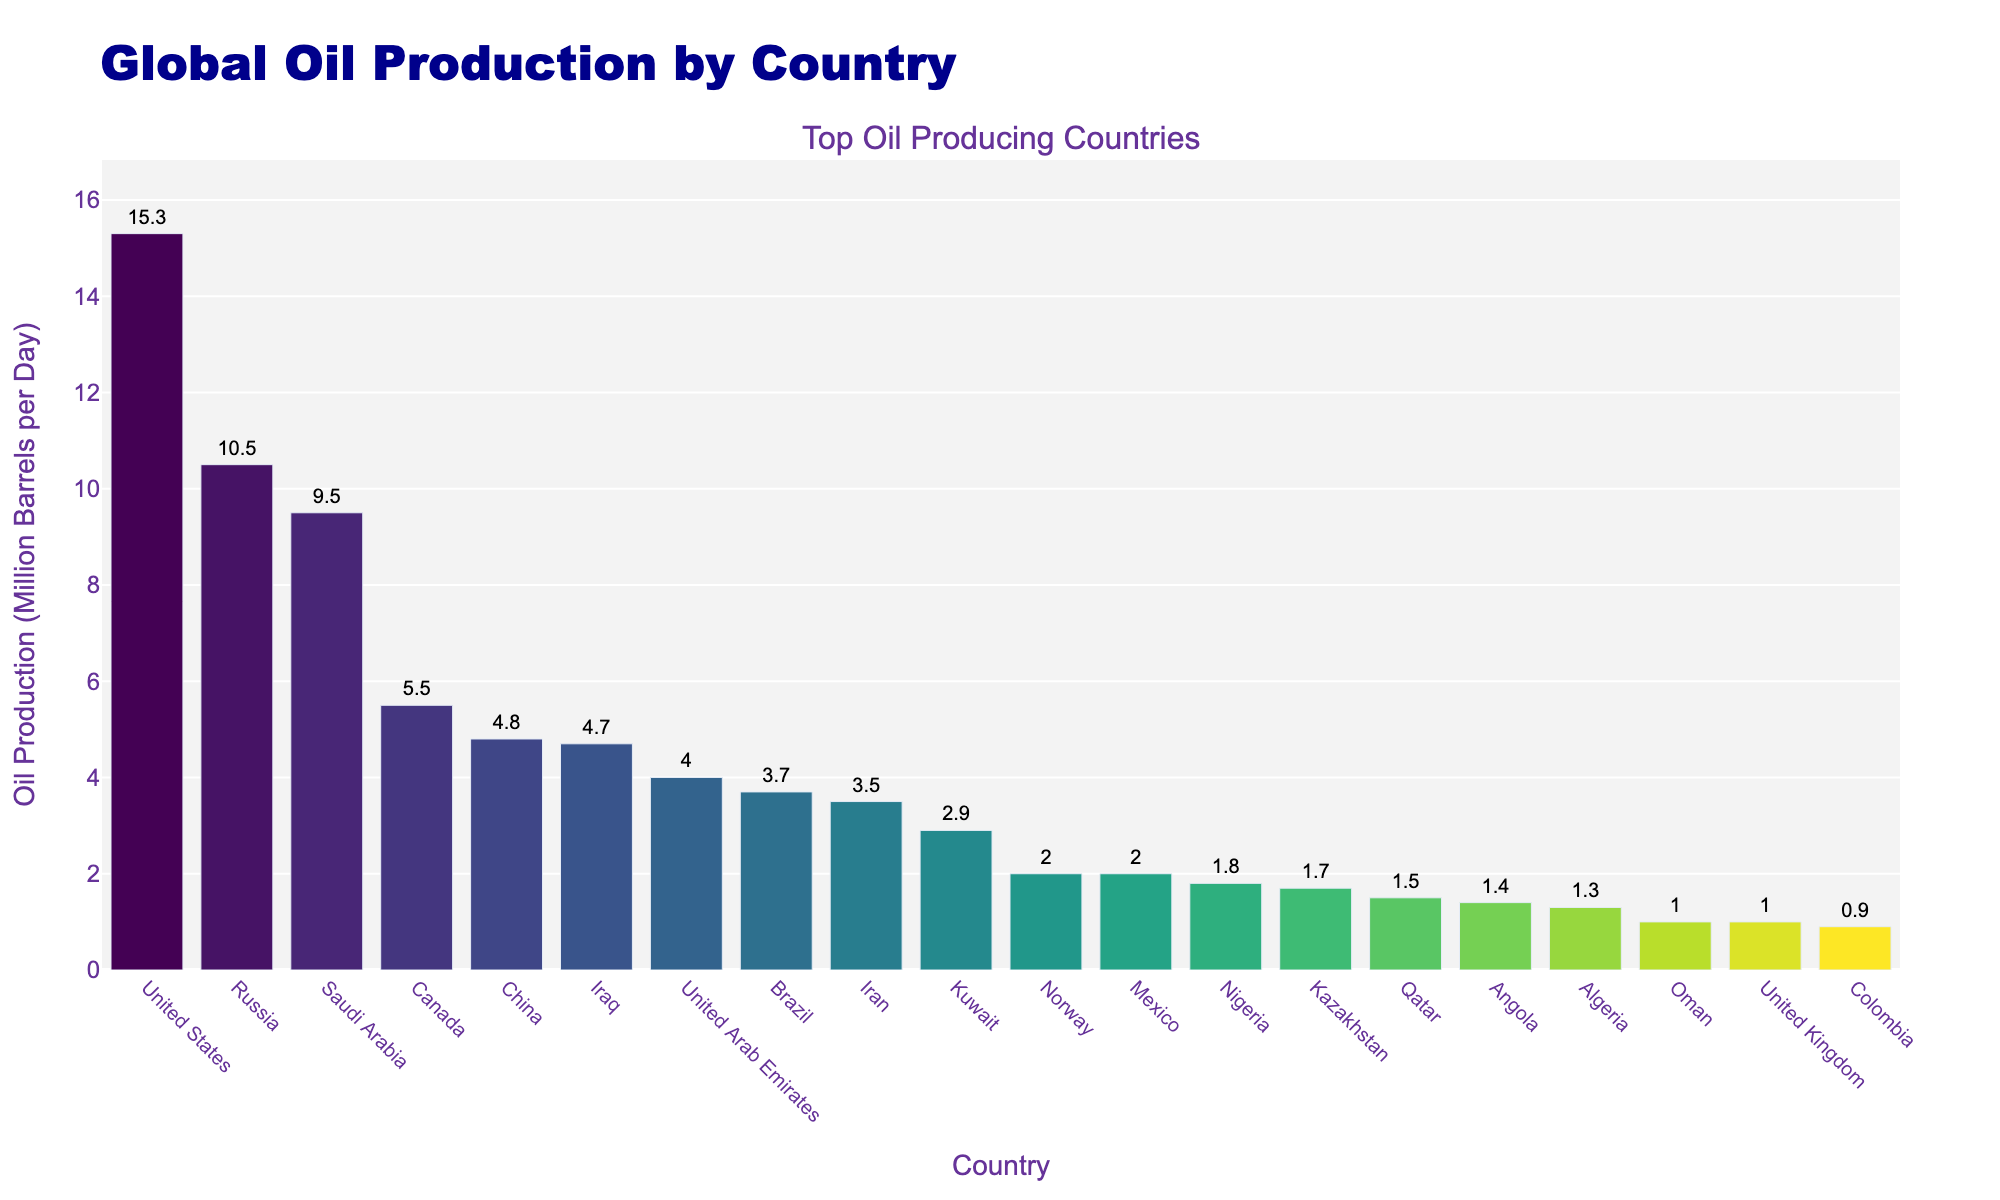What's the average oil production of the top 5 countries? To find the average, first add the production values of the top 5 countries: 15.3 (United States) + 10.5 (Russia) + 9.5 (Saudi Arabia) + 5.5 (Canada) + 4.8 (China) = 45.6. Then, divide by the number of countries, which is 5. So, 45.6 / 5 = 9.12
Answer: 9.12 Which country has the second-highest oil production? By observing the height of the bars, the one before the tallest bar is Russia with an oil production of 10.5 million barrels per day.
Answer: Russia Which country produces more oil: Iraq or Iran? By comparing the height of the bars for Iraq and Iran, Iraq produces 4.7 million barrels per day while Iran produces 3.5 million barrels per day, so Iraq produces more oil.
Answer: Iraq What is the difference in oil production between Brazil and Kuwait? Brazil produces 3.7 million barrels per day and Kuwait produces 2.9 million barrels per day. Subtracting these values gives 3.7 - 2.9 = 0.8.
Answer: 0.8 How many countries produce more than 4 million barrels of oil per day? By counting the bars that exceed the 4 million barrels per day mark, the countries are United States, Russia, Saudi Arabia, Canada, and China, totaling 5 countries.
Answer: 5 Compare the oil production of the United Arab Emirates and Mexico. Which one is greater? By how much? The United Arab Emirates produces 4.0 million barrels per day and Mexico produces 2.0 million barrels per day. The difference is 4.0 - 2.0 = 2.0, so UAE produces 2.0 million barrels per day more than Mexico.
Answer: UAE, 2.0 What is the combined oil production of Nigeria, Kazakhstan, and Colombia? Adding up the production values: 1.8 (Nigeria) + 1.7 (Kazakhstan) + 0.9 (Colombia) = 4.4 million barrels per day.
Answer: 4.4 Which country produces the least amount of oil and how much? By observing the shortest bar, Colombia produces the least amount of oil, which is 0.9 million barrels per day.
Answer: Colombia, 0.9 Is the oil production of Canada closer to that of Saudi Arabia or China? Canada's production is 5.5 million barrels per day. The difference with Saudi Arabia's 9.5 million is 9.5 - 5.5 = 4.0. The difference with China's 4.8 million is 5.5 - 4.8 = 0.7. Therefore, it's closer to China's production.
Answer: China What is the median production value of the top 10 oil-producing countries? List the production values in order: 15.3, 10.5, 9.5, 5.5, 4.8, 4.7, 4.0, 3.7, 3.5, 2.9. The median is the average of the 5th and 6th values: (4.8 + 4.7) / 2 = 4.75.
Answer: 4.75 